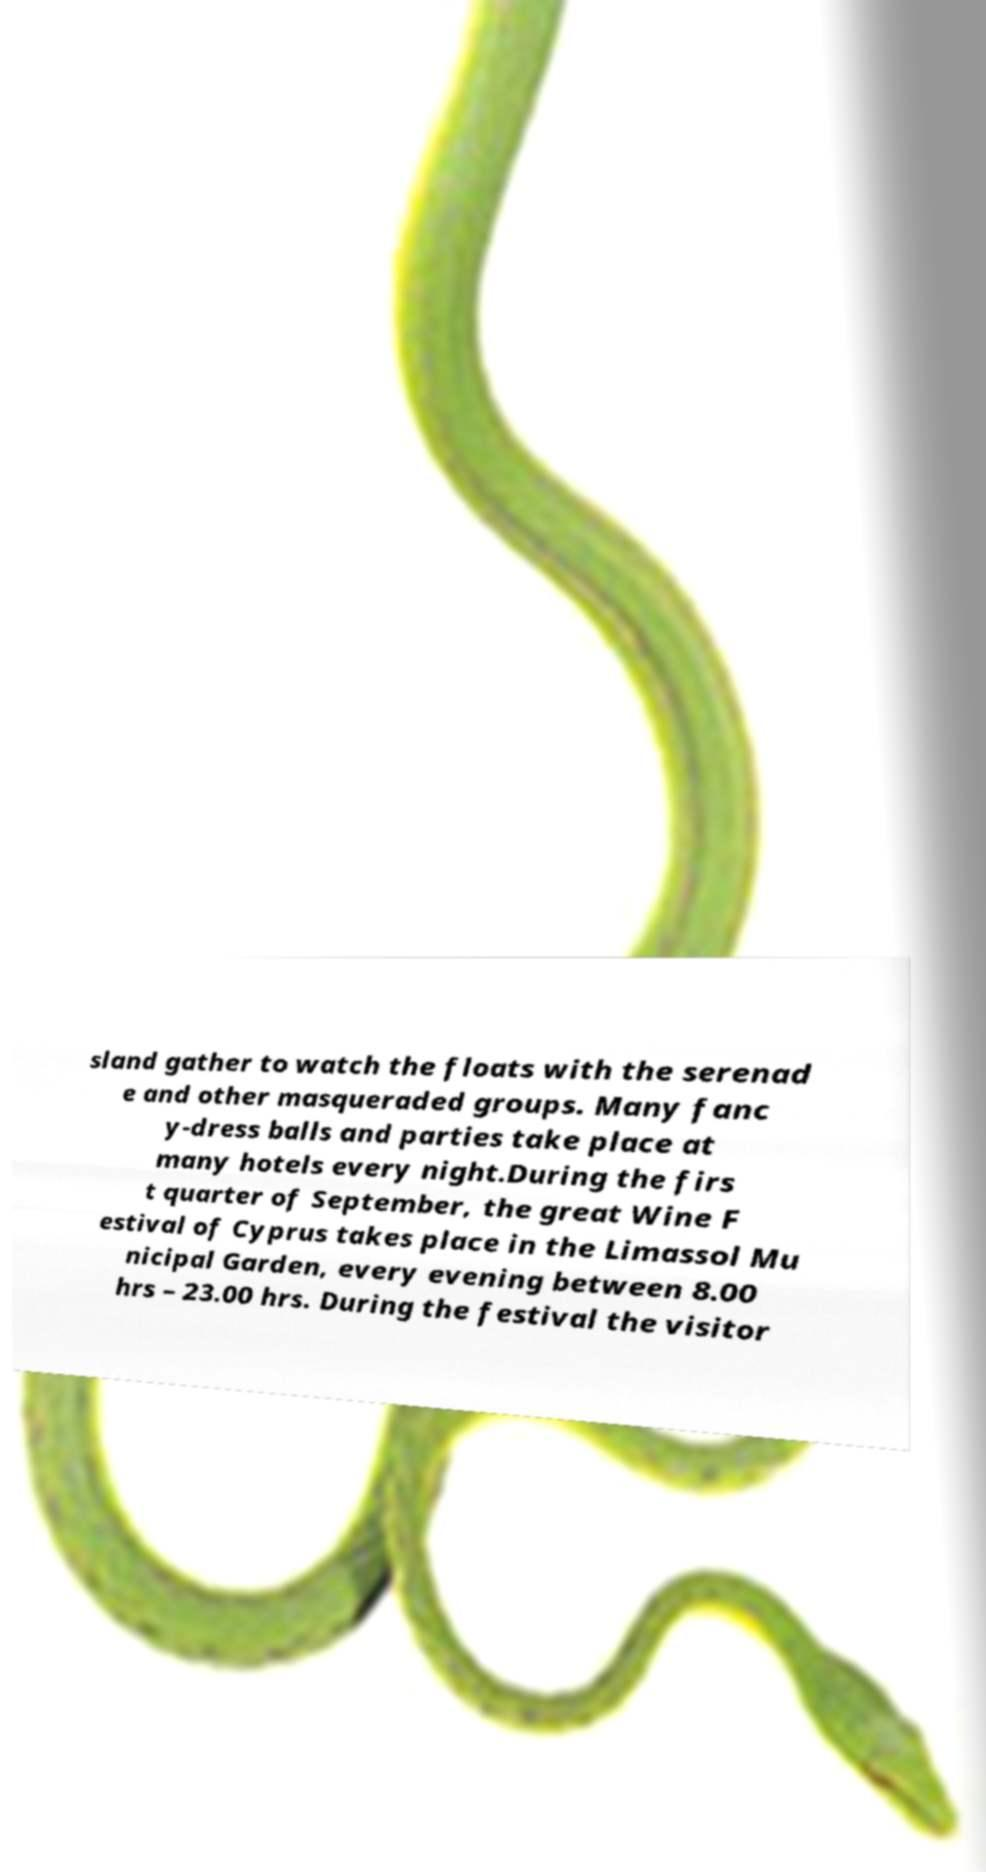There's text embedded in this image that I need extracted. Can you transcribe it verbatim? sland gather to watch the floats with the serenad e and other masqueraded groups. Many fanc y-dress balls and parties take place at many hotels every night.During the firs t quarter of September, the great Wine F estival of Cyprus takes place in the Limassol Mu nicipal Garden, every evening between 8.00 hrs – 23.00 hrs. During the festival the visitor 